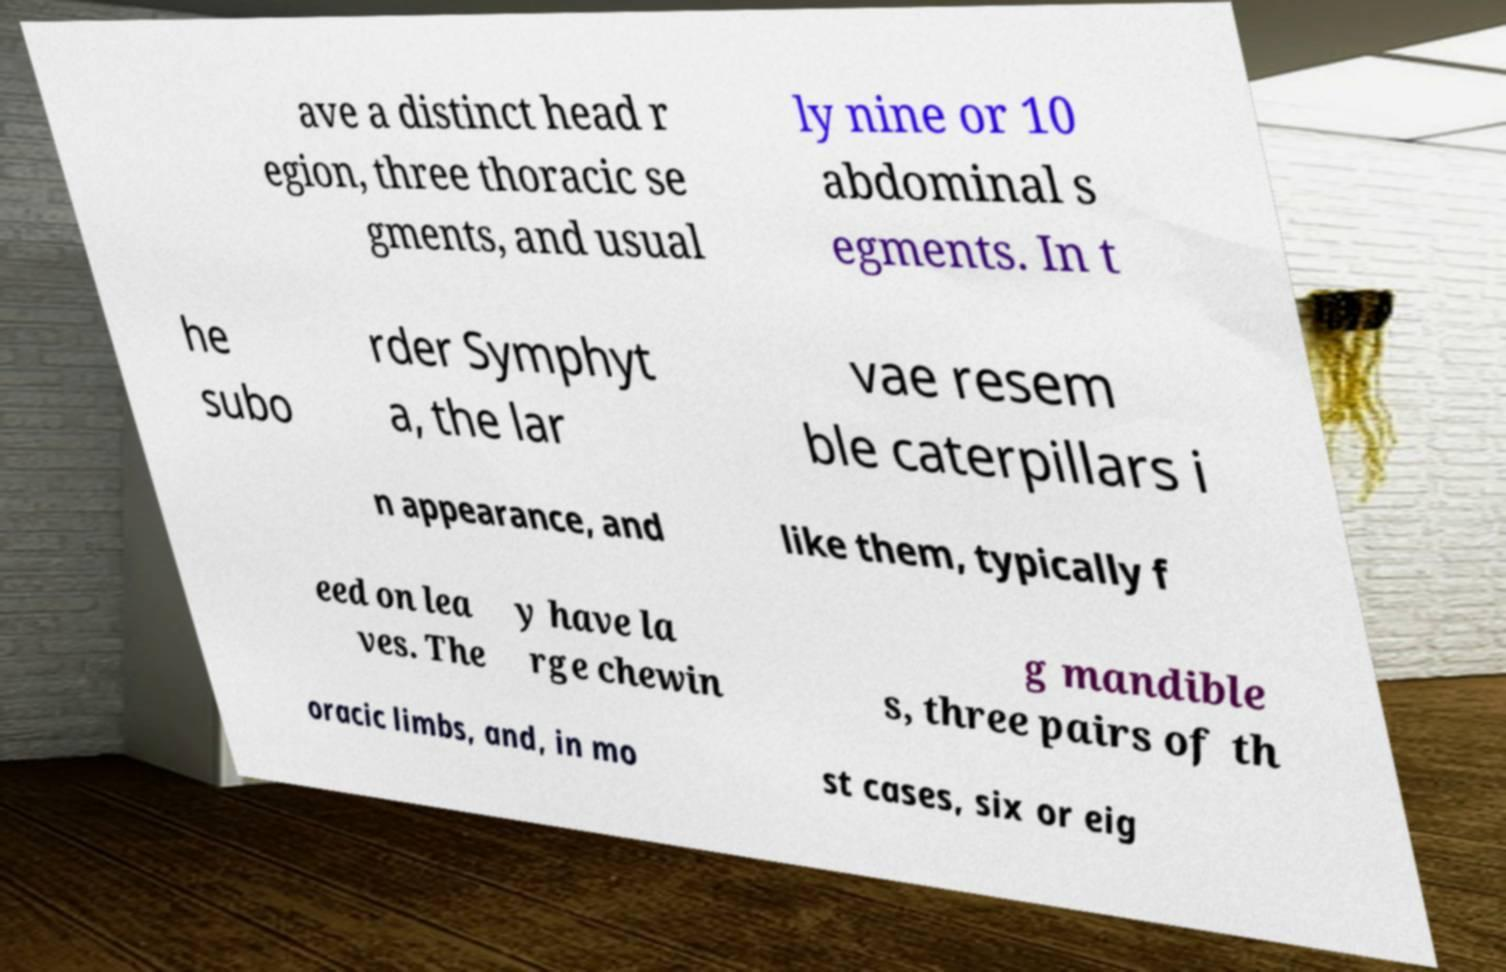For documentation purposes, I need the text within this image transcribed. Could you provide that? ave a distinct head r egion, three thoracic se gments, and usual ly nine or 10 abdominal s egments. In t he subo rder Symphyt a, the lar vae resem ble caterpillars i n appearance, and like them, typically f eed on lea ves. The y have la rge chewin g mandible s, three pairs of th oracic limbs, and, in mo st cases, six or eig 